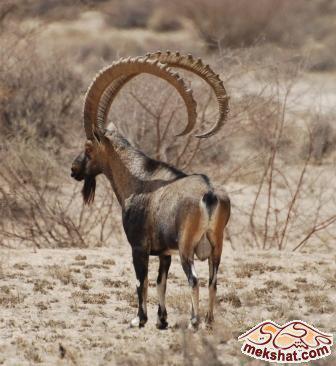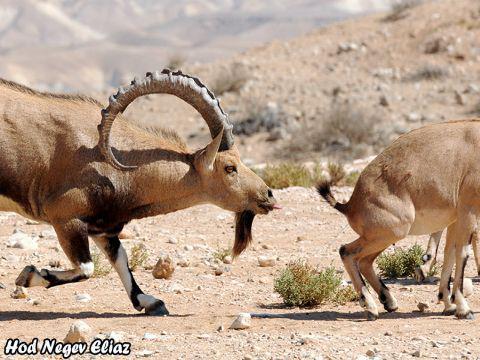The first image is the image on the left, the second image is the image on the right. For the images shown, is this caption "The left and right image contains three horned goats." true? Answer yes or no. No. The first image is the image on the left, the second image is the image on the right. Assess this claim about the two images: "In one of the images, the heads of two goats are visible.". Correct or not? Answer yes or no. No. 